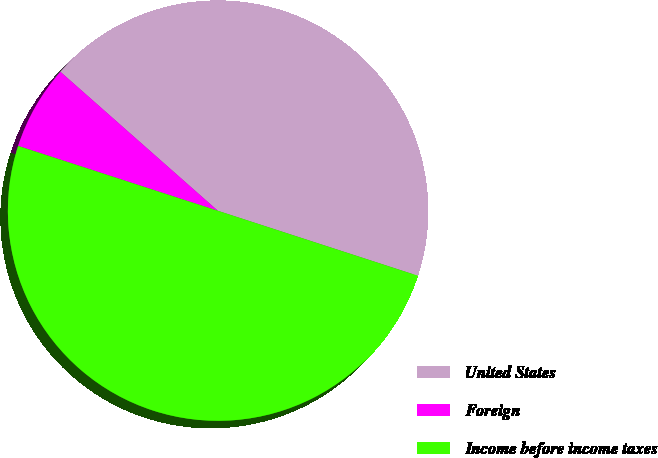Convert chart to OTSL. <chart><loc_0><loc_0><loc_500><loc_500><pie_chart><fcel>United States<fcel>Foreign<fcel>Income before income taxes<nl><fcel>43.49%<fcel>6.51%<fcel>50.0%<nl></chart> 